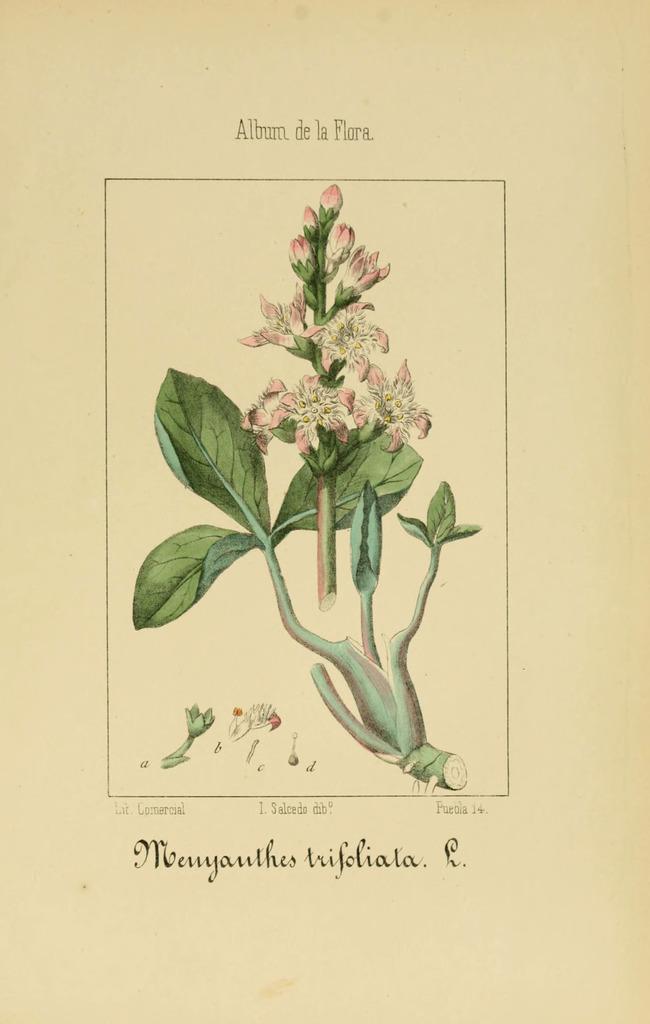In one or two sentences, can you explain what this image depicts? In this picture we can the flowers, but, leaves are present. At the bottom of the image some text is there. 